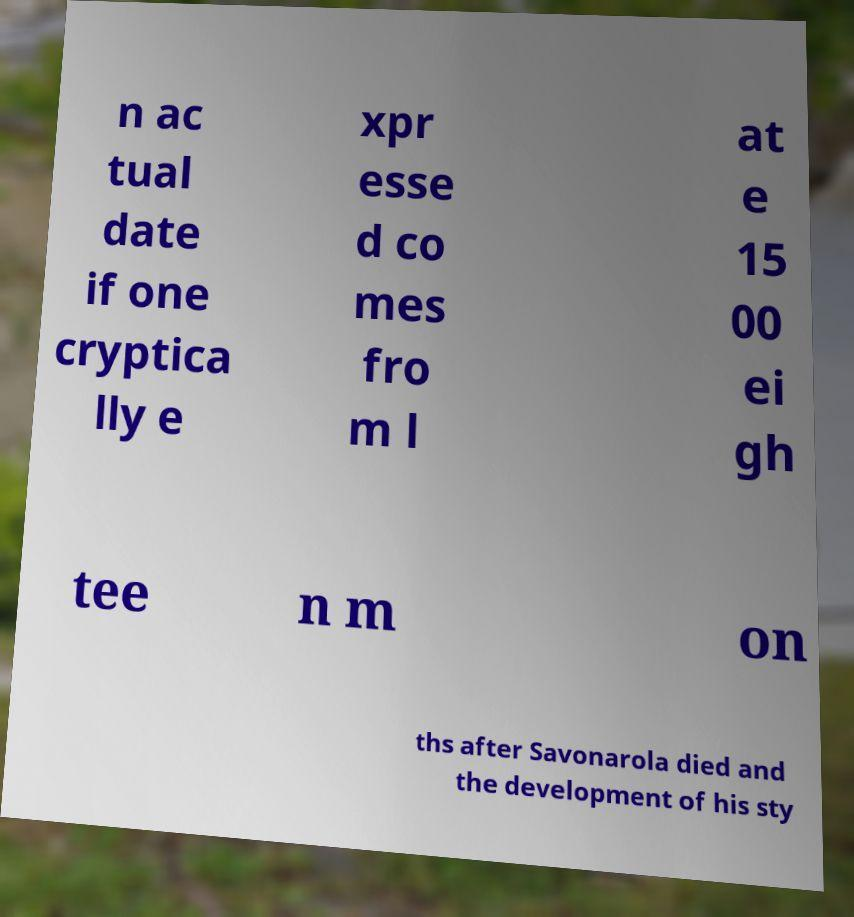There's text embedded in this image that I need extracted. Can you transcribe it verbatim? n ac tual date if one cryptica lly e xpr esse d co mes fro m l at e 15 00 ei gh tee n m on ths after Savonarola died and the development of his sty 